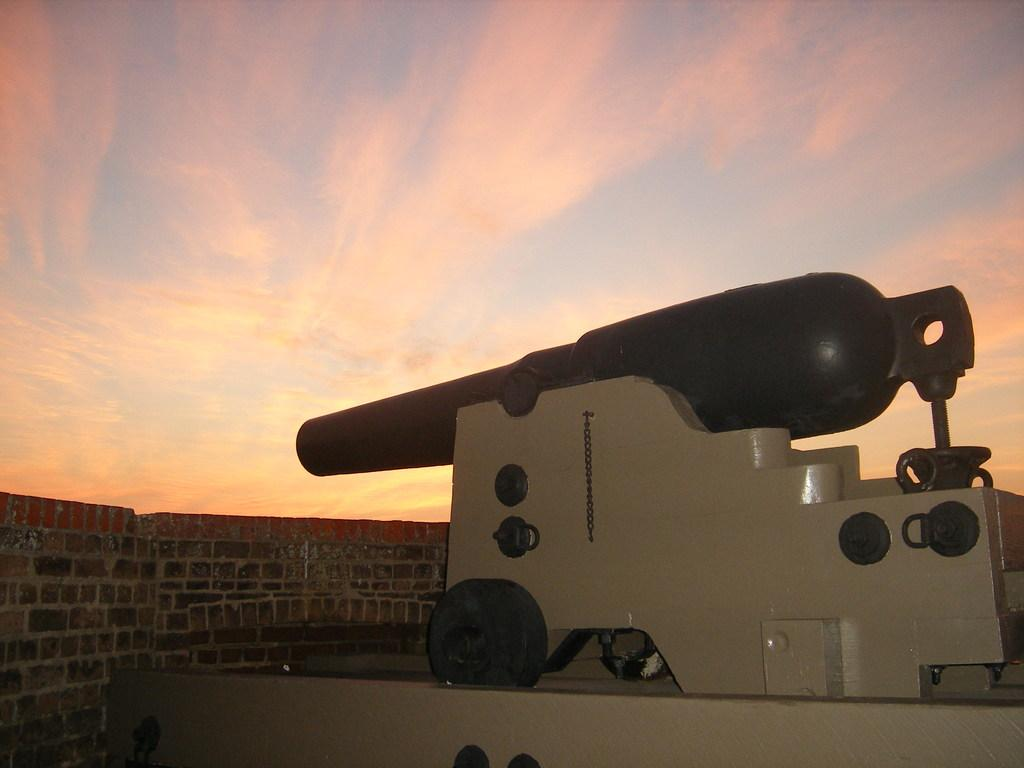What is the main object in the image? There is a cannon in the image. What can be seen in the background of the image? There is a sky and a wall visible in the background of the image. What type of silk is draped over the cannon in the image? There is no silk present in the image; it only features a cannon and the background. 